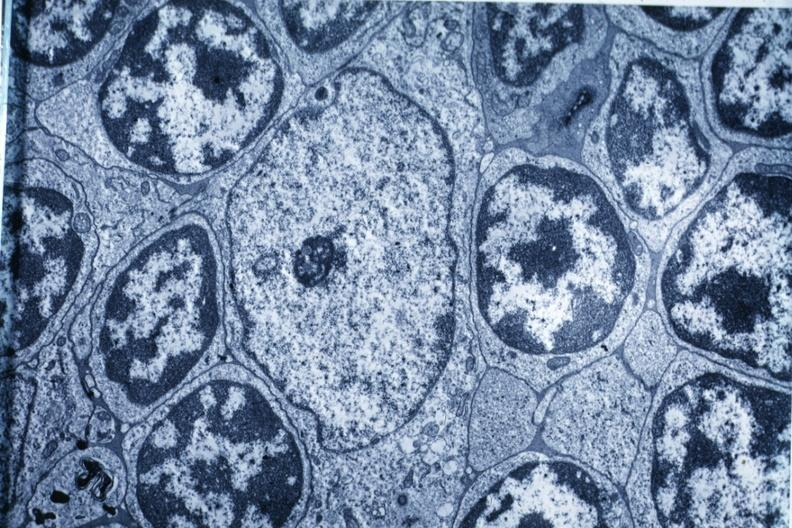what is present?
Answer the question using a single word or phrase. Thymus 